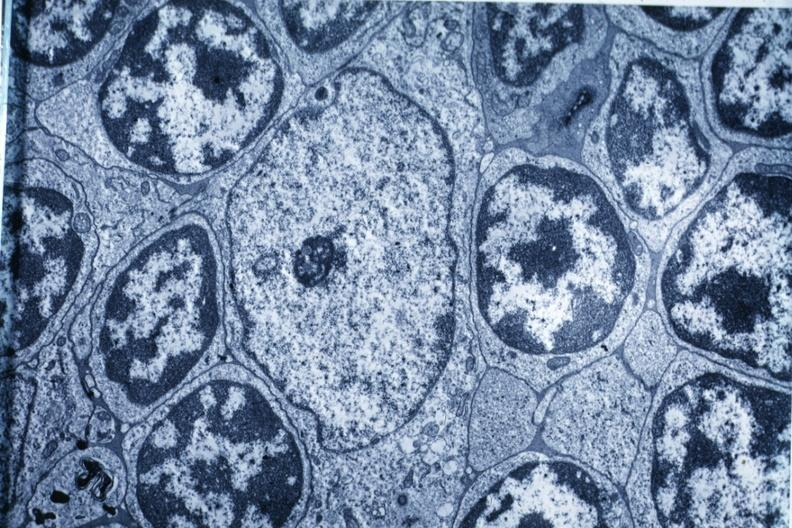what is present?
Answer the question using a single word or phrase. Thymus 